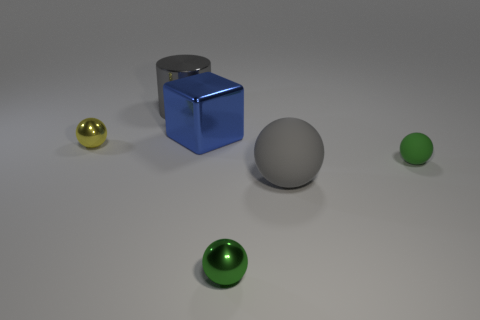Subtract all gray balls. How many balls are left? 3 Subtract all gray matte balls. How many balls are left? 3 Add 1 big cyan rubber blocks. How many objects exist? 7 Subtract all cyan balls. Subtract all cyan cylinders. How many balls are left? 4 Subtract all blocks. How many objects are left? 5 Add 5 tiny gray matte blocks. How many tiny gray matte blocks exist? 5 Subtract 1 blue blocks. How many objects are left? 5 Subtract all large gray rubber cubes. Subtract all small matte balls. How many objects are left? 5 Add 3 tiny yellow balls. How many tiny yellow balls are left? 4 